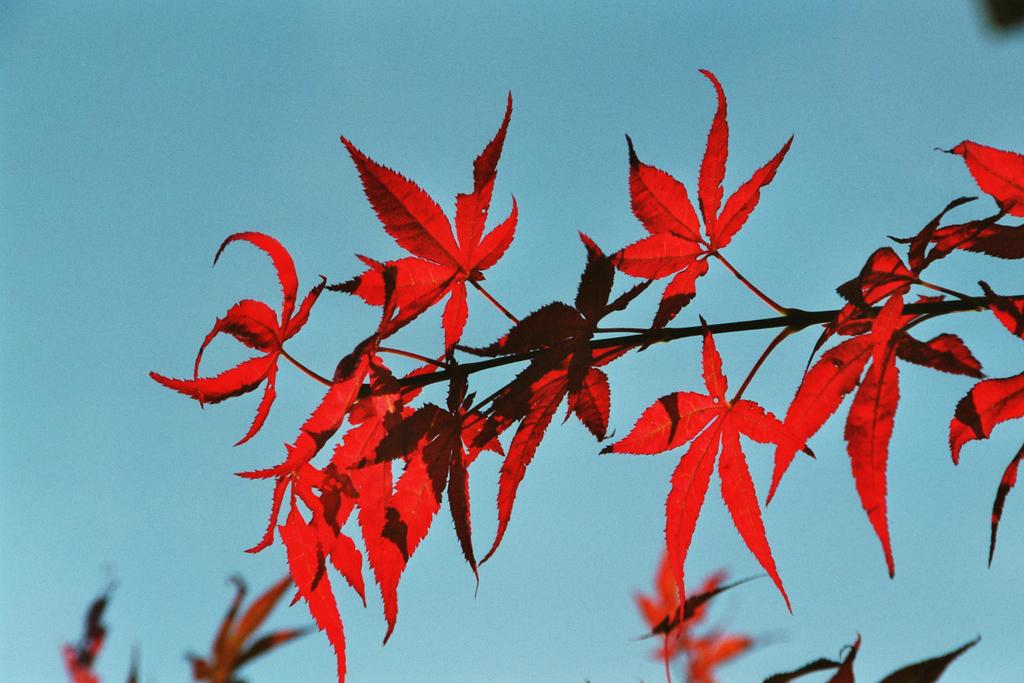What is the main subject of the picture? The main subject of the picture is a plant. What color are the leaves of the plant? The leaves of the plant have a red color. Are there any other leaves visible in the image? Yes, there are additional leaves in the backdrop of the plant. What is the condition of the sky in the picture? The sky is clear in the picture. Can you tell me how many bulbs are hanging from the plant in the image? There are no bulbs present in the image; it features a plant with red leaves and additional leaves in the backdrop. What type of beetle can be seen crawling on the leaves of the plant in the image? There are no beetles present on the leaves of the plant in the image. 